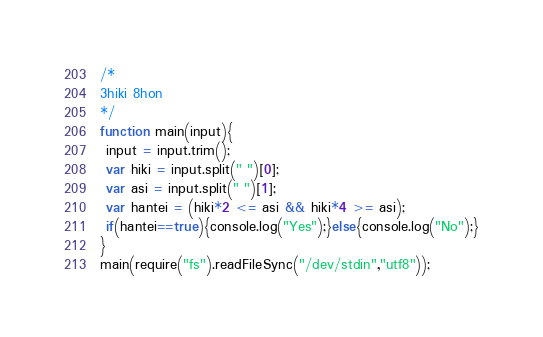Convert code to text. <code><loc_0><loc_0><loc_500><loc_500><_JavaScript_>/*
3hiki 8hon
*/
function main(input){
 input = input.trim();
 var hiki = input.split(" ")[0];
 var asi = input.split(" ")[1];
 var hantei = (hiki*2 <= asi && hiki*4 >= asi);
 if(hantei==true){console.log("Yes");}else{console.log("No");}
}
main(require("fs").readFileSync("/dev/stdin","utf8"));</code> 